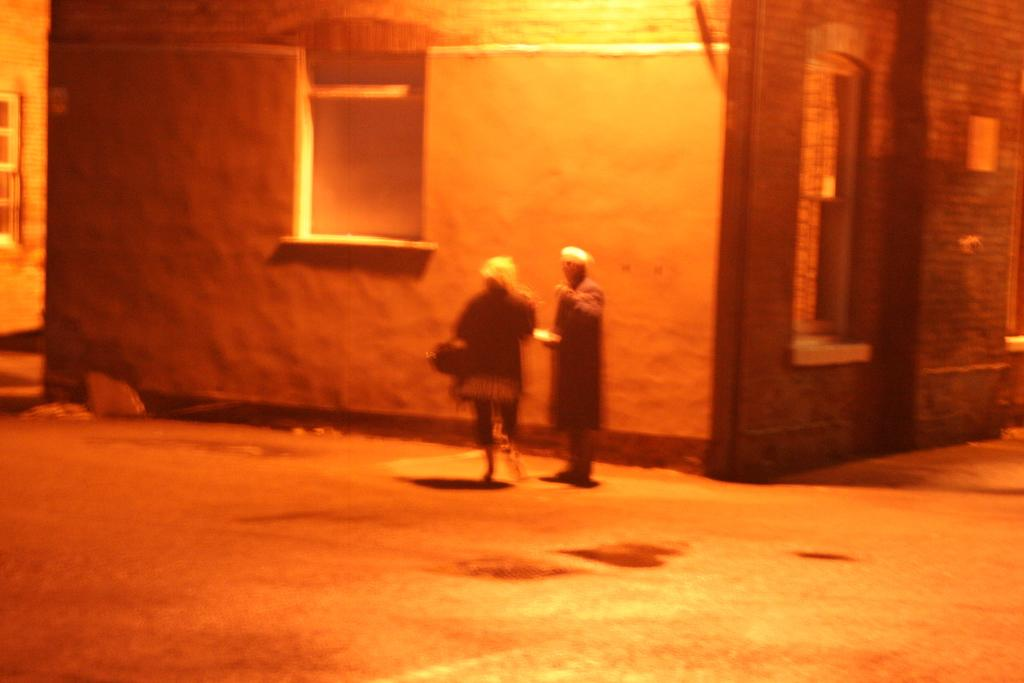What is the overall lighting condition in the image? The image is dark. What type of surface can be seen in the image? There is ground visible in the image. Are there any living beings present in the image? Yes, there are people standing on the ground. What type of structures are present in the image? There are buildings in the image. What feature of the buildings is visible in the image? Windows are visible on the buildings. What type of chain can be seen hanging from the windows in the image? There is no chain visible in the image; only the windows on the buildings are present. Is there a bath visible in the image? No, there is no bath present in the image. 